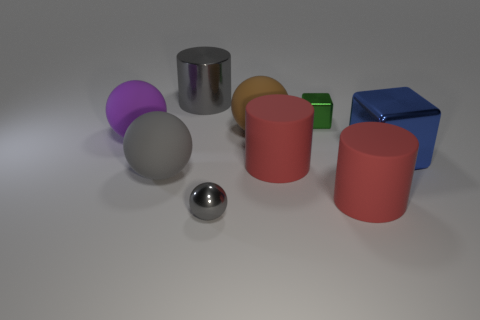Add 1 green matte cylinders. How many objects exist? 10 Subtract all cubes. How many objects are left? 7 Subtract 0 cyan cylinders. How many objects are left? 9 Subtract all gray metallic cylinders. Subtract all purple matte objects. How many objects are left? 7 Add 4 red objects. How many red objects are left? 6 Add 2 large red matte things. How many large red matte things exist? 4 